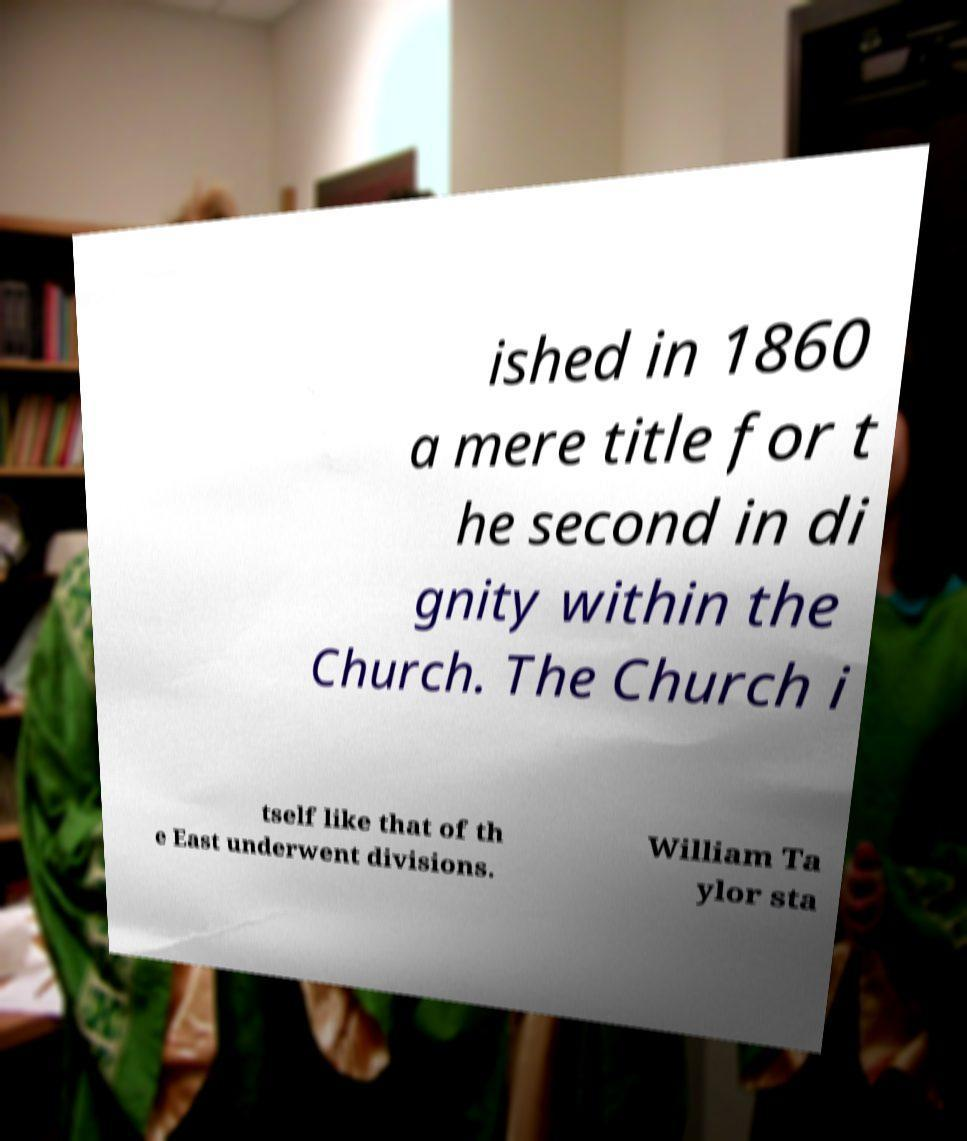Please identify and transcribe the text found in this image. ished in 1860 a mere title for t he second in di gnity within the Church. The Church i tself like that of th e East underwent divisions. William Ta ylor sta 